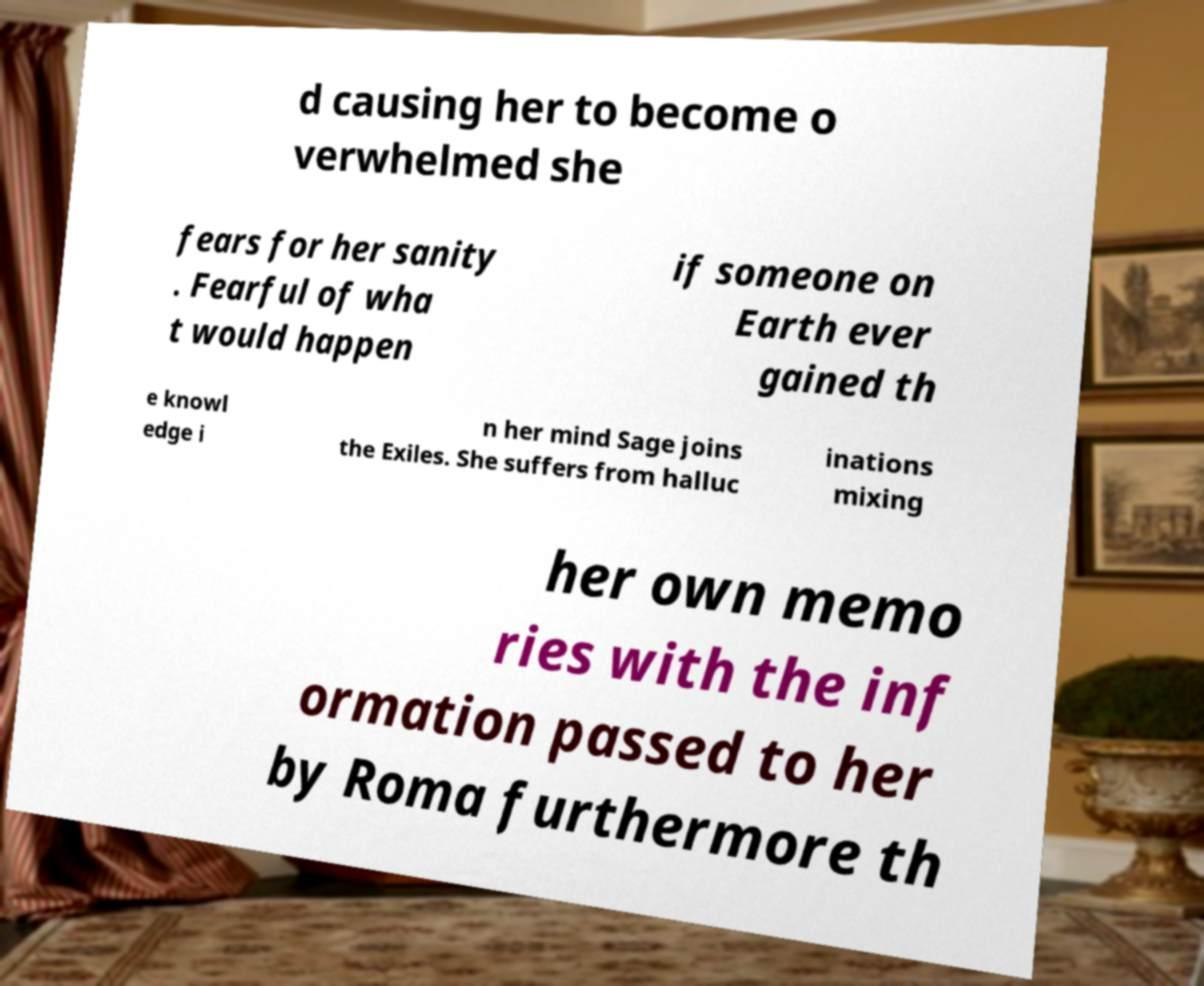Can you accurately transcribe the text from the provided image for me? d causing her to become o verwhelmed she fears for her sanity . Fearful of wha t would happen if someone on Earth ever gained th e knowl edge i n her mind Sage joins the Exiles. She suffers from halluc inations mixing her own memo ries with the inf ormation passed to her by Roma furthermore th 